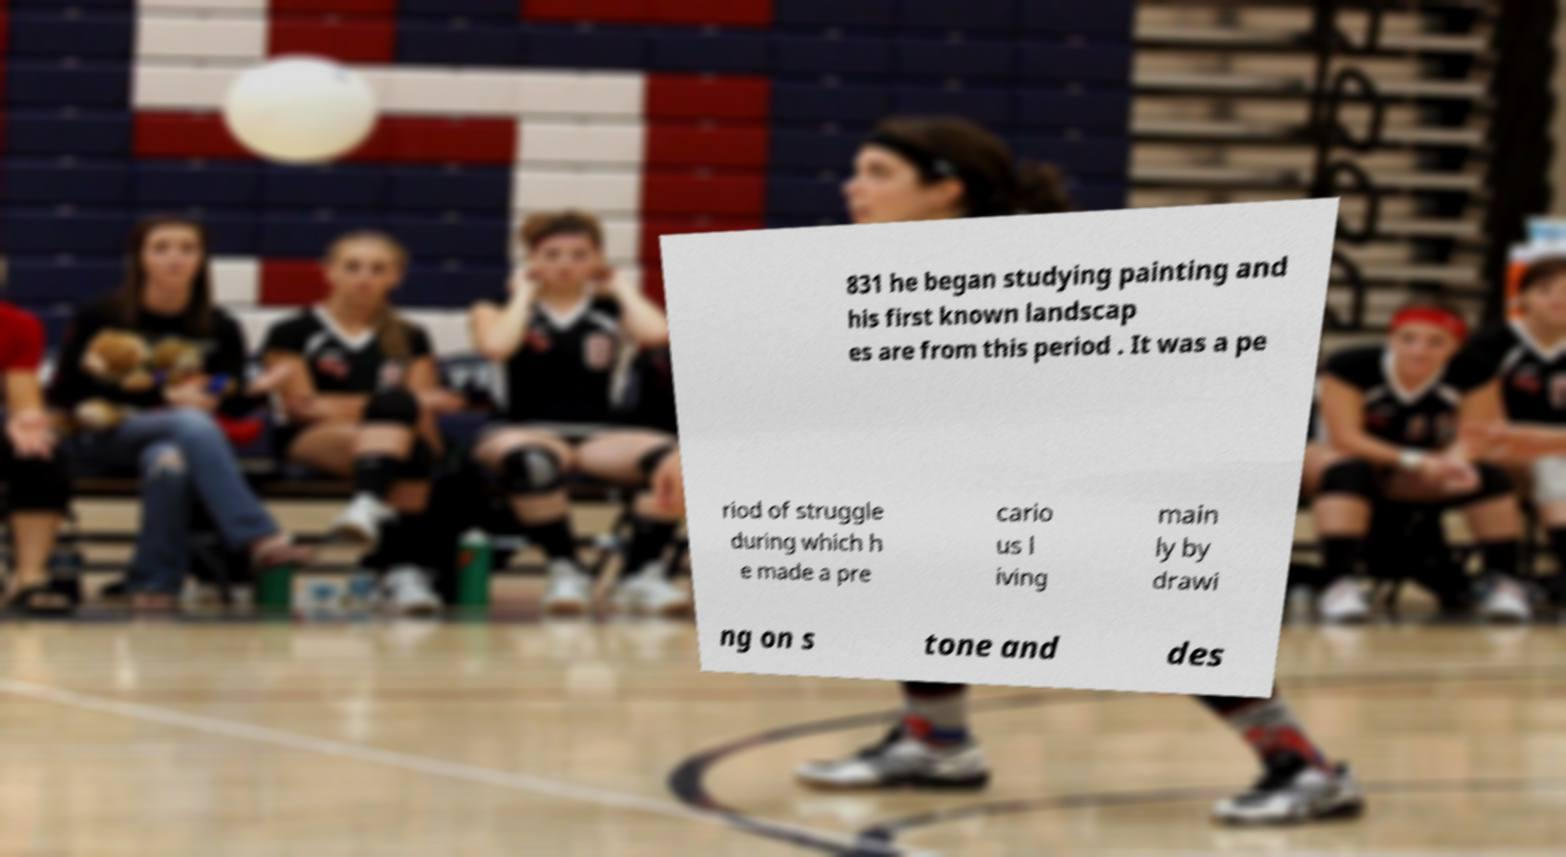There's text embedded in this image that I need extracted. Can you transcribe it verbatim? 831 he began studying painting and his first known landscap es are from this period . It was a pe riod of struggle during which h e made a pre cario us l iving main ly by drawi ng on s tone and des 